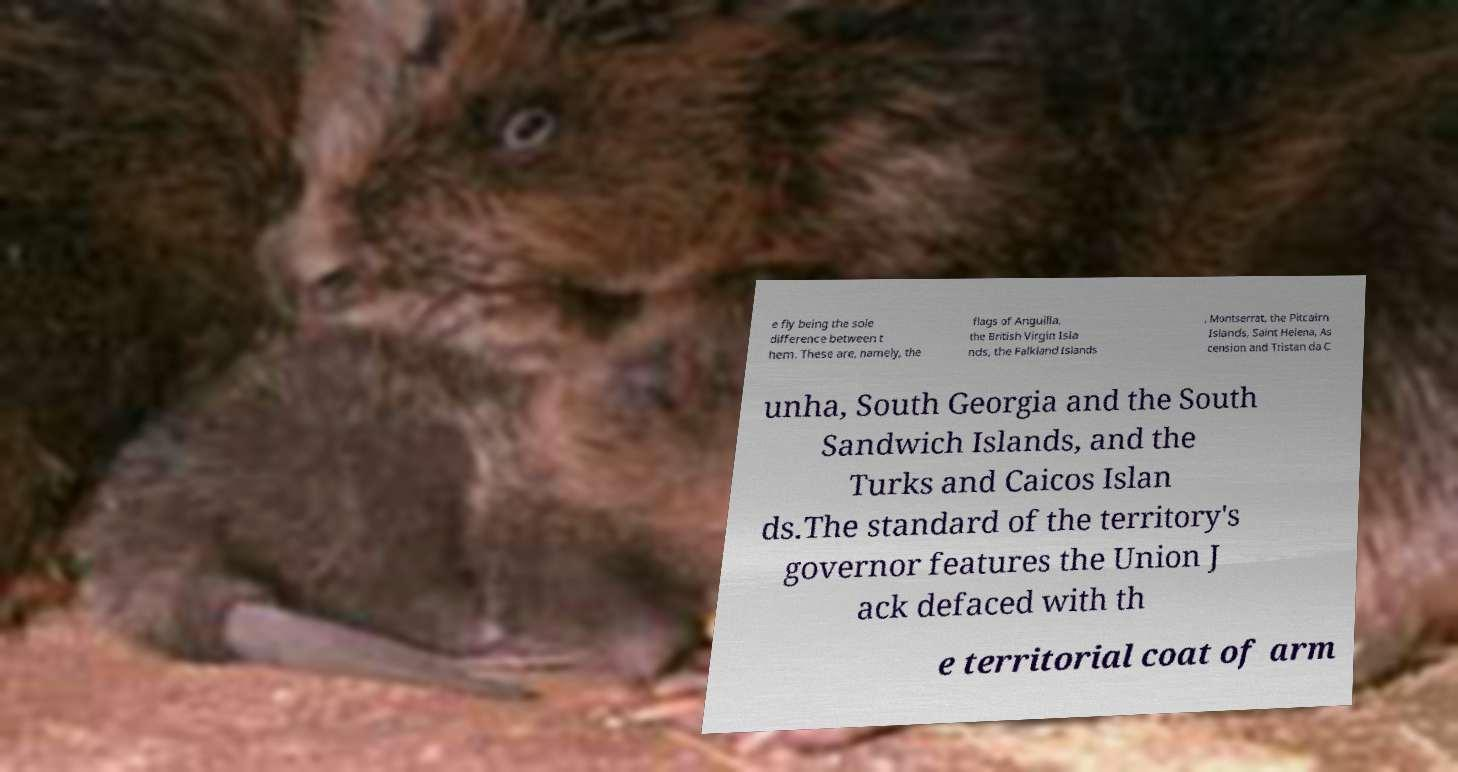There's text embedded in this image that I need extracted. Can you transcribe it verbatim? e fly being the sole difference between t hem. These are, namely, the flags of Anguilla, the British Virgin Isla nds, the Falkland Islands , Montserrat, the Pitcairn Islands, Saint Helena, As cension and Tristan da C unha, South Georgia and the South Sandwich Islands, and the Turks and Caicos Islan ds.The standard of the territory's governor features the Union J ack defaced with th e territorial coat of arm 